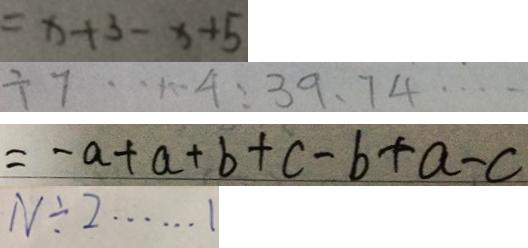<formula> <loc_0><loc_0><loc_500><loc_500>= x + 3 - x + 5 
 \div 7 \cdots 4 : 3 9 、 7 4 \cdots 
 = - a + a + b + c - b + a - c 
 N \div 2 \cdots 1</formula> 